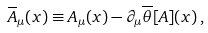<formula> <loc_0><loc_0><loc_500><loc_500>\overline { A } _ { \mu } ( x ) \equiv A _ { \mu } ( x ) - \partial _ { \mu } \overline { \theta } [ A ] ( x ) \, ,</formula> 